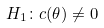Convert formula to latex. <formula><loc_0><loc_0><loc_500><loc_500>H _ { 1 } \colon c ( \theta ) \ne 0</formula> 